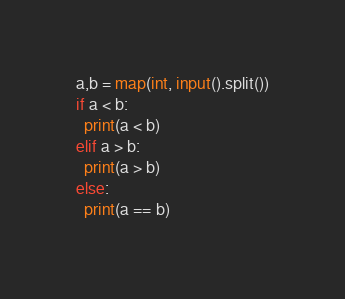Convert code to text. <code><loc_0><loc_0><loc_500><loc_500><_Python_>a,b = map(int, input().split())
if a < b:
  print(a < b)
elif a > b:
  print(a > b)
else:
  print(a == b)
</code> 